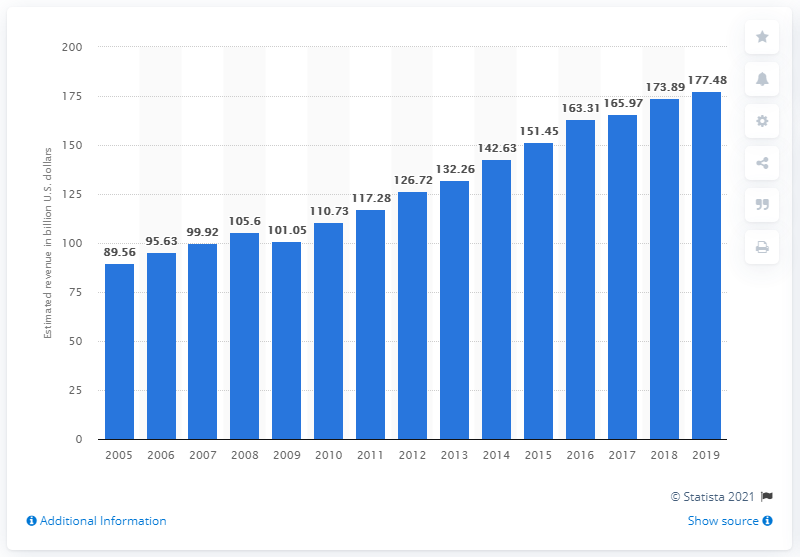Indicate a few pertinent items in this graphic. In 2019, the total revenue of the American broadcasting industry was 177.48 billion dollars. The total revenue of the American broadcasting industry in 2018 was 173.89 billion dollars. The annual aggregate revenue of the U.S. broadcasting industry reached its highest point in the time frame from 2005 to 2019 in 2019. 